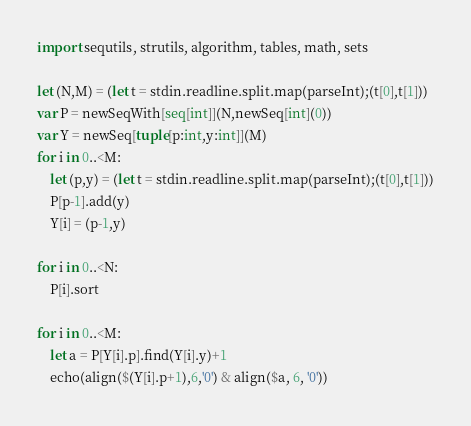<code> <loc_0><loc_0><loc_500><loc_500><_Nim_>import sequtils, strutils, algorithm, tables, math, sets

let (N,M) = (let t = stdin.readline.split.map(parseInt);(t[0],t[1]))
var P = newSeqWith[seq[int]](N,newSeq[int](0))
var Y = newSeq[tuple[p:int,y:int]](M)
for i in 0..<M:
    let (p,y) = (let t = stdin.readline.split.map(parseInt);(t[0],t[1]))
    P[p-1].add(y)
    Y[i] = (p-1,y)

for i in 0..<N:
    P[i].sort

for i in 0..<M:
    let a = P[Y[i].p].find(Y[i].y)+1
    echo(align($(Y[i].p+1),6,'0') & align($a, 6, '0'))</code> 